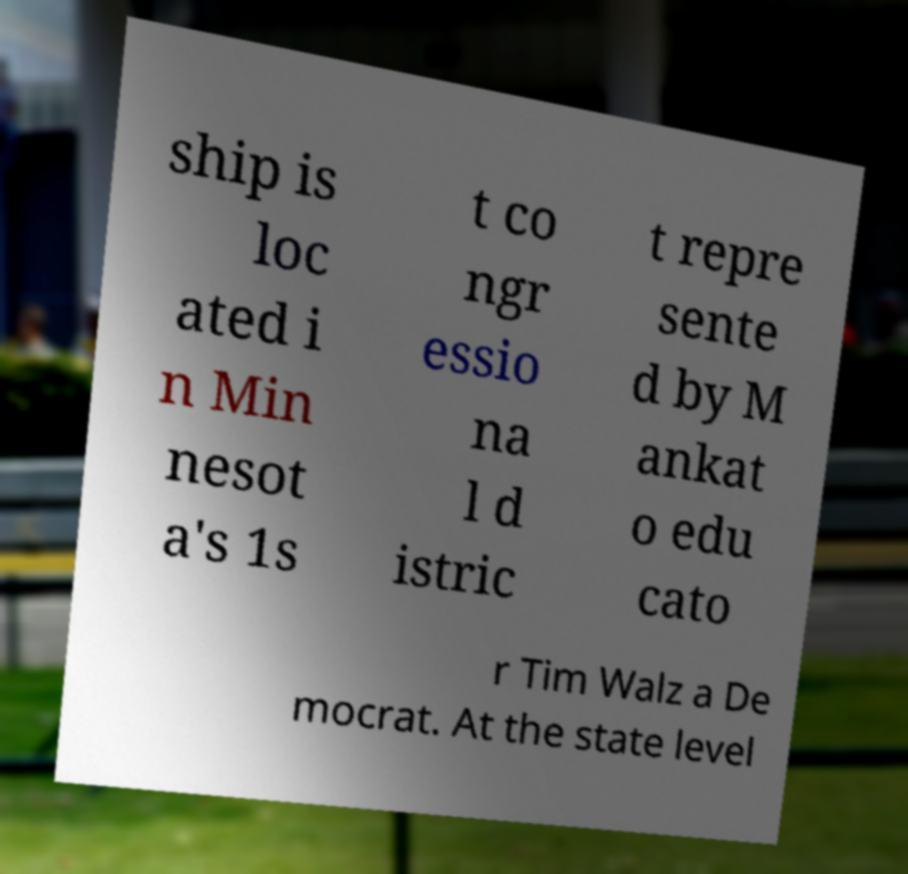I need the written content from this picture converted into text. Can you do that? ship is loc ated i n Min nesot a's 1s t co ngr essio na l d istric t repre sente d by M ankat o edu cato r Tim Walz a De mocrat. At the state level 